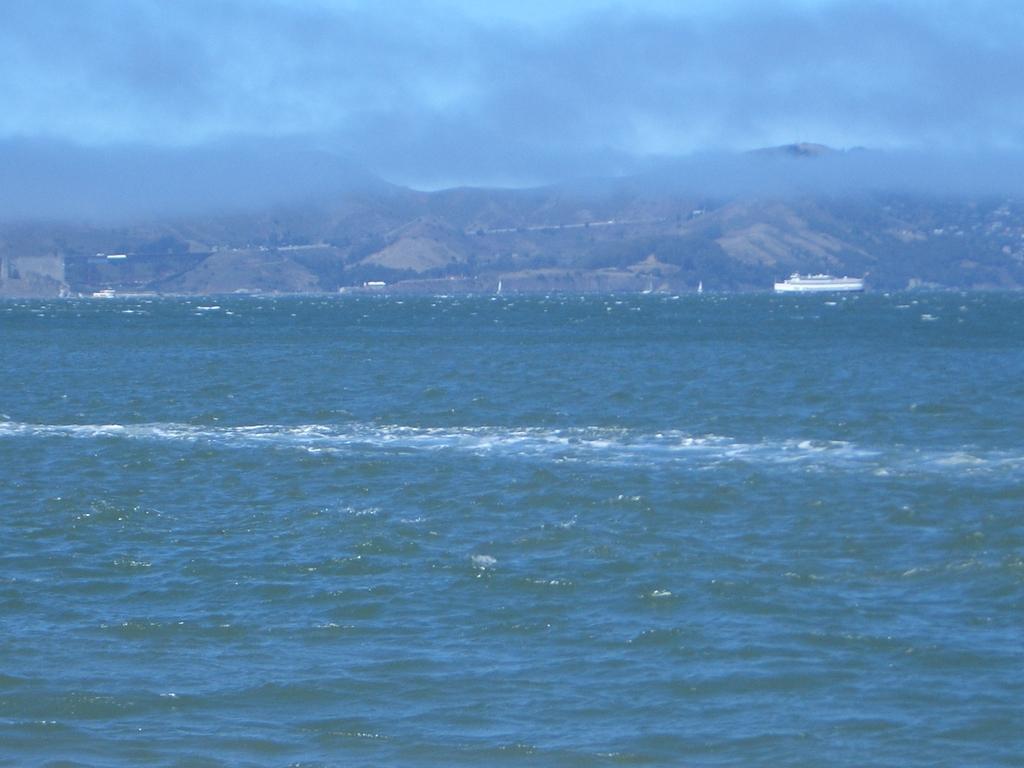How would you summarize this image in a sentence or two? In this picture we can see a boat on water, mountains and in the background we can see the sky with clouds. 